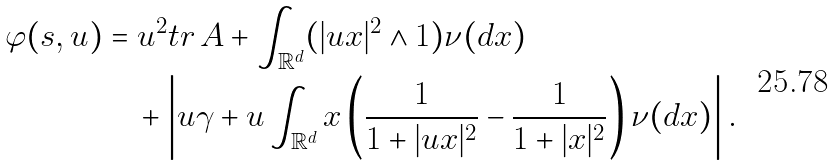Convert formula to latex. <formula><loc_0><loc_0><loc_500><loc_500>\varphi ( s , u ) & = u ^ { 2 } t r \, A + \int _ { \mathbb { R } ^ { d } } ( | u x | ^ { 2 } \land 1 ) \nu ( d x ) \\ & \quad + \left | u \gamma + u \int _ { \mathbb { R } ^ { d } } x \left ( \frac { 1 } { 1 + | u x | ^ { 2 } } - \frac { 1 } { 1 + | x | ^ { 2 } } \right ) \nu ( d x ) \right | .</formula> 